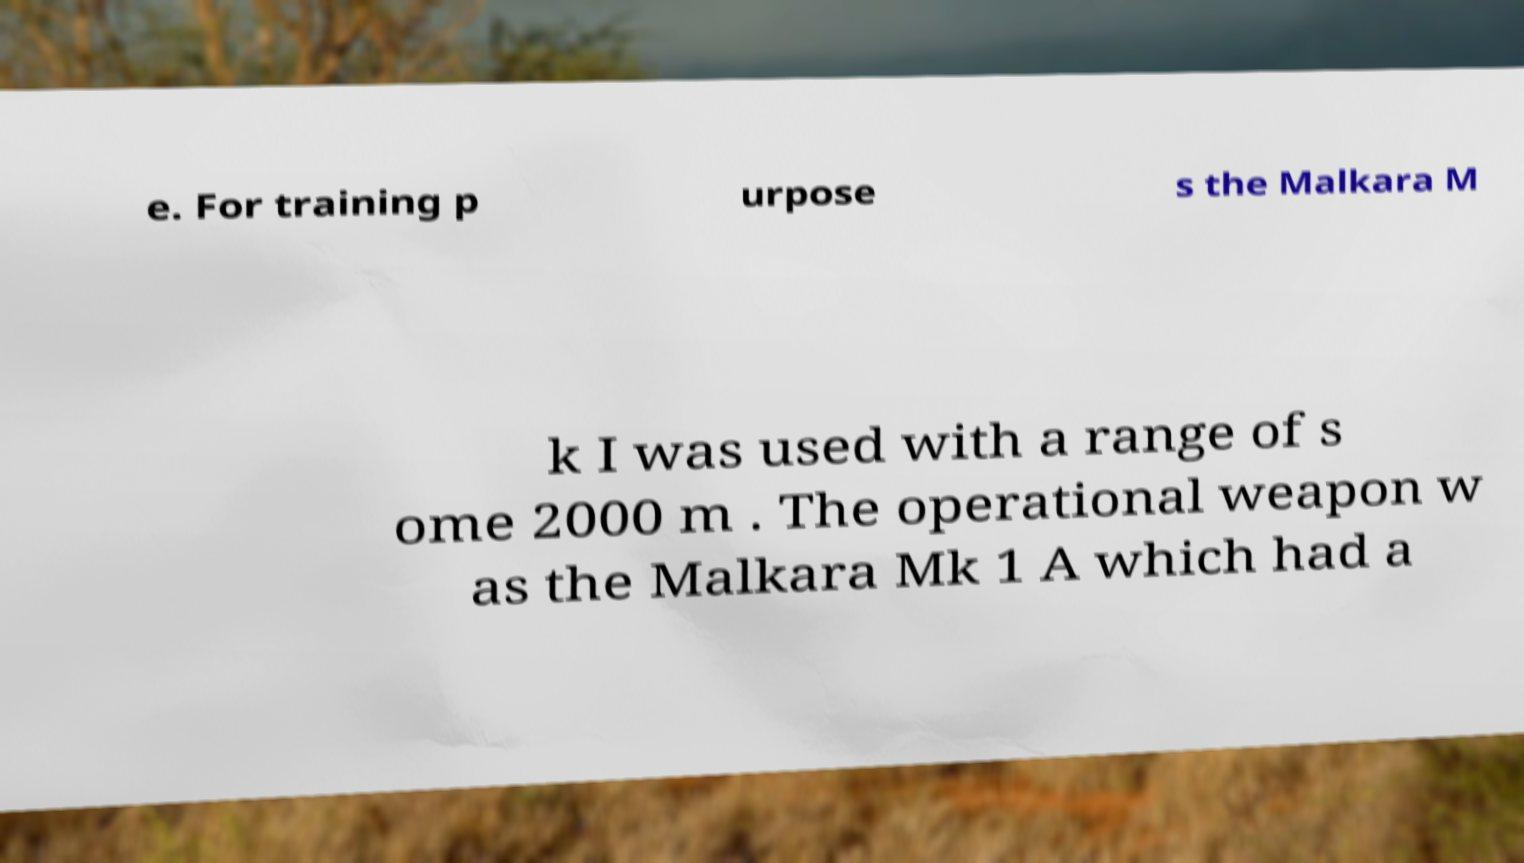Can you read and provide the text displayed in the image?This photo seems to have some interesting text. Can you extract and type it out for me? e. For training p urpose s the Malkara M k I was used with a range of s ome 2000 m . The operational weapon w as the Malkara Mk 1 A which had a 